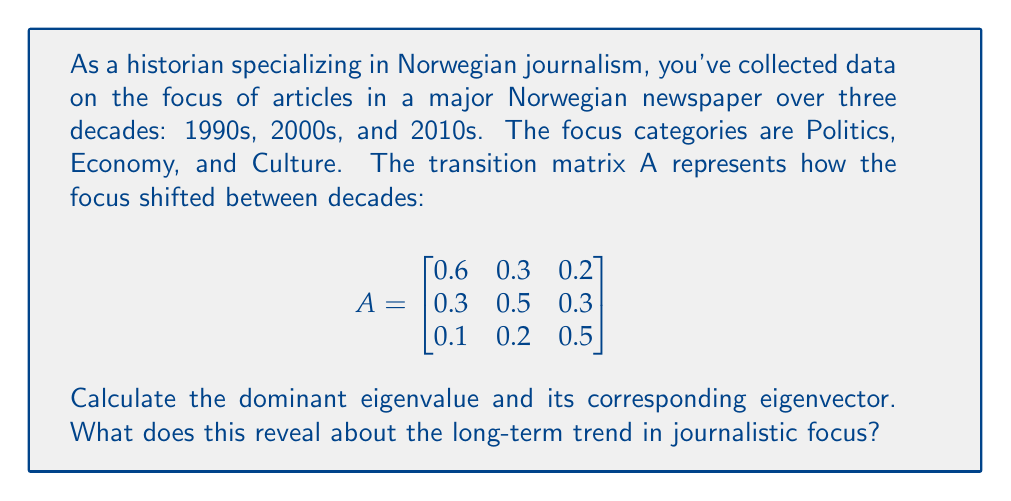Can you solve this math problem? To solve this problem, we'll follow these steps:

1) Find the characteristic equation:
   $det(A - \lambda I) = 0$

2) Solve for eigenvalues:
   $\begin{vmatrix}
   0.6-\lambda & 0.3 & 0.2 \\
   0.3 & 0.5-\lambda & 0.3 \\
   0.1 & 0.2 & 0.5-\lambda
   \end{vmatrix} = 0$

   $(0.6-\lambda)[(0.5-\lambda)(0.5-\lambda)-0.06] - 0.3[0.3(0.5-\lambda)-0.06] + 0.2[0.09-0.1(0.5-\lambda)] = 0$

   Simplifying: $-\lambda^3 + 1.6\lambda^2 - 0.71\lambda + 0.096 = 0$

3) The solutions to this equation are the eigenvalues. The dominant eigenvalue is the largest in magnitude: $\lambda_1 \approx 1$

4) For $\lambda_1 = 1$, solve $(A - I)v = 0$ to find the corresponding eigenvector:

   $$\begin{bmatrix}
   -0.4 & 0.3 & 0.2 \\
   0.3 & -0.5 & 0.3 \\
   0.1 & 0.2 & -0.5
   \end{bmatrix} \begin{bmatrix} v_1 \\ v_2 \\ v_3 \end{bmatrix} = \begin{bmatrix} 0 \\ 0 \\ 0 \end{bmatrix}$$

5) Solving this system gives the eigenvector: $v \approx [0.4, 0.4, 0.2]^T$

Interpretation: The dominant eigenvalue of 1 indicates a stable long-term distribution. The corresponding eigenvector [0.4, 0.4, 0.2] suggests that in the long run, the focus will stabilize with approximately 40% on Politics, 40% on Economy, and 20% on Culture.
Answer: Dominant eigenvalue: 1; Eigenvector: [0.4, 0.4, 0.2]. Long-term trend: 40% Politics, 40% Economy, 20% Culture. 